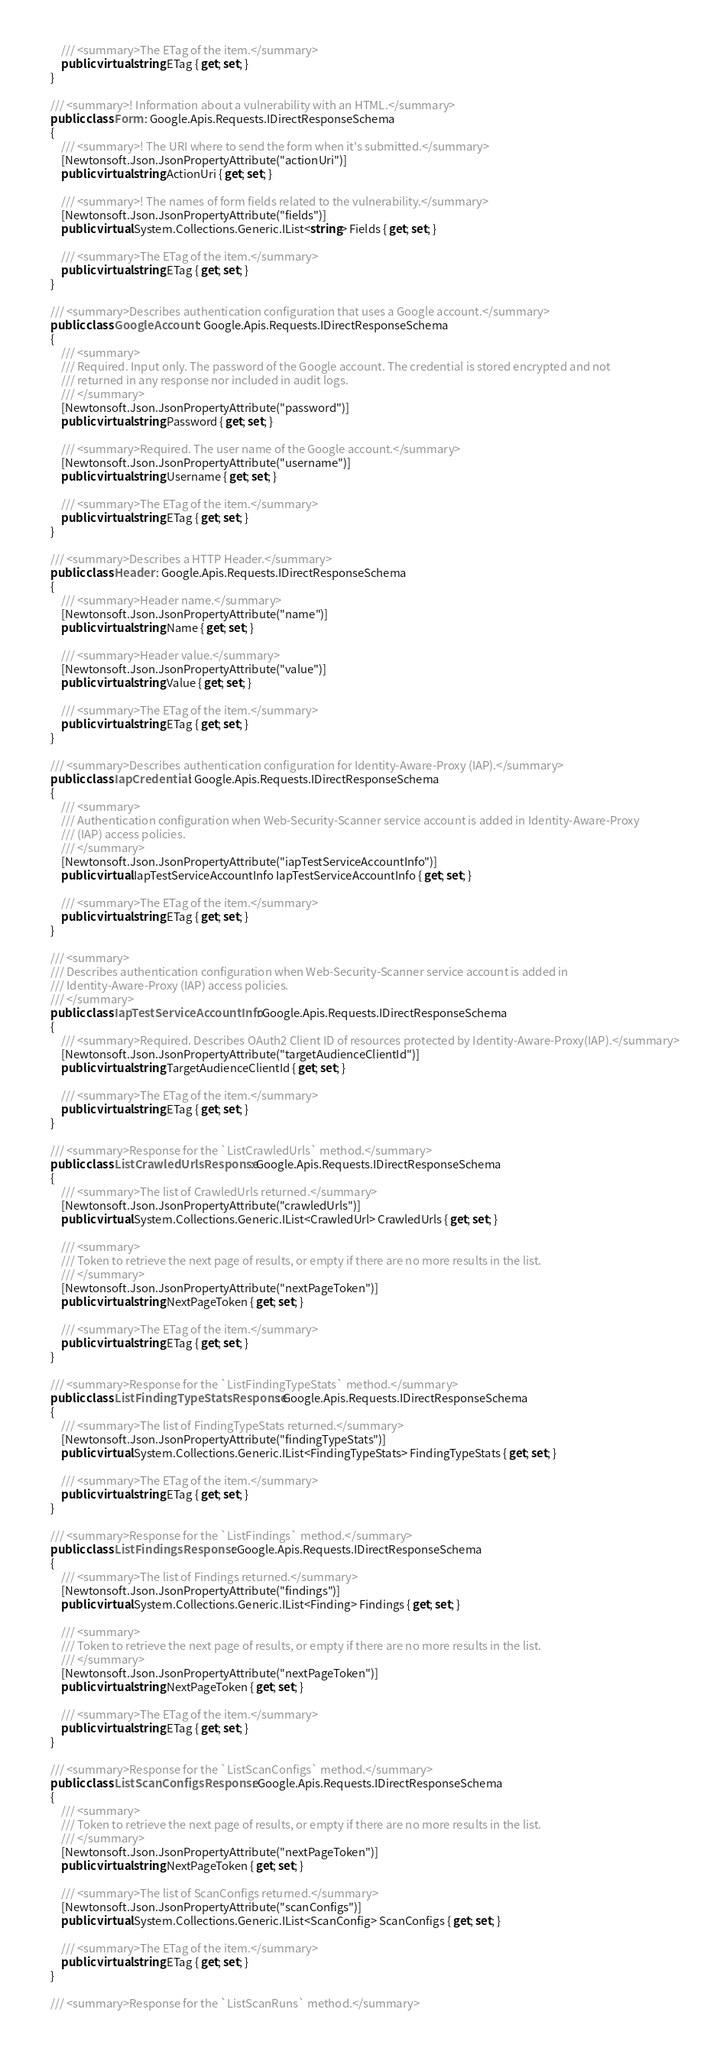Convert code to text. <code><loc_0><loc_0><loc_500><loc_500><_C#_>
        /// <summary>The ETag of the item.</summary>
        public virtual string ETag { get; set; }
    }

    /// <summary>! Information about a vulnerability with an HTML.</summary>
    public class Form : Google.Apis.Requests.IDirectResponseSchema
    {
        /// <summary>! The URI where to send the form when it's submitted.</summary>
        [Newtonsoft.Json.JsonPropertyAttribute("actionUri")]
        public virtual string ActionUri { get; set; }

        /// <summary>! The names of form fields related to the vulnerability.</summary>
        [Newtonsoft.Json.JsonPropertyAttribute("fields")]
        public virtual System.Collections.Generic.IList<string> Fields { get; set; }

        /// <summary>The ETag of the item.</summary>
        public virtual string ETag { get; set; }
    }

    /// <summary>Describes authentication configuration that uses a Google account.</summary>
    public class GoogleAccount : Google.Apis.Requests.IDirectResponseSchema
    {
        /// <summary>
        /// Required. Input only. The password of the Google account. The credential is stored encrypted and not
        /// returned in any response nor included in audit logs.
        /// </summary>
        [Newtonsoft.Json.JsonPropertyAttribute("password")]
        public virtual string Password { get; set; }

        /// <summary>Required. The user name of the Google account.</summary>
        [Newtonsoft.Json.JsonPropertyAttribute("username")]
        public virtual string Username { get; set; }

        /// <summary>The ETag of the item.</summary>
        public virtual string ETag { get; set; }
    }

    /// <summary>Describes a HTTP Header.</summary>
    public class Header : Google.Apis.Requests.IDirectResponseSchema
    {
        /// <summary>Header name.</summary>
        [Newtonsoft.Json.JsonPropertyAttribute("name")]
        public virtual string Name { get; set; }

        /// <summary>Header value.</summary>
        [Newtonsoft.Json.JsonPropertyAttribute("value")]
        public virtual string Value { get; set; }

        /// <summary>The ETag of the item.</summary>
        public virtual string ETag { get; set; }
    }

    /// <summary>Describes authentication configuration for Identity-Aware-Proxy (IAP).</summary>
    public class IapCredential : Google.Apis.Requests.IDirectResponseSchema
    {
        /// <summary>
        /// Authentication configuration when Web-Security-Scanner service account is added in Identity-Aware-Proxy
        /// (IAP) access policies.
        /// </summary>
        [Newtonsoft.Json.JsonPropertyAttribute("iapTestServiceAccountInfo")]
        public virtual IapTestServiceAccountInfo IapTestServiceAccountInfo { get; set; }

        /// <summary>The ETag of the item.</summary>
        public virtual string ETag { get; set; }
    }

    /// <summary>
    /// Describes authentication configuration when Web-Security-Scanner service account is added in
    /// Identity-Aware-Proxy (IAP) access policies.
    /// </summary>
    public class IapTestServiceAccountInfo : Google.Apis.Requests.IDirectResponseSchema
    {
        /// <summary>Required. Describes OAuth2 Client ID of resources protected by Identity-Aware-Proxy(IAP).</summary>
        [Newtonsoft.Json.JsonPropertyAttribute("targetAudienceClientId")]
        public virtual string TargetAudienceClientId { get; set; }

        /// <summary>The ETag of the item.</summary>
        public virtual string ETag { get; set; }
    }

    /// <summary>Response for the `ListCrawledUrls` method.</summary>
    public class ListCrawledUrlsResponse : Google.Apis.Requests.IDirectResponseSchema
    {
        /// <summary>The list of CrawledUrls returned.</summary>
        [Newtonsoft.Json.JsonPropertyAttribute("crawledUrls")]
        public virtual System.Collections.Generic.IList<CrawledUrl> CrawledUrls { get; set; }

        /// <summary>
        /// Token to retrieve the next page of results, or empty if there are no more results in the list.
        /// </summary>
        [Newtonsoft.Json.JsonPropertyAttribute("nextPageToken")]
        public virtual string NextPageToken { get; set; }

        /// <summary>The ETag of the item.</summary>
        public virtual string ETag { get; set; }
    }

    /// <summary>Response for the `ListFindingTypeStats` method.</summary>
    public class ListFindingTypeStatsResponse : Google.Apis.Requests.IDirectResponseSchema
    {
        /// <summary>The list of FindingTypeStats returned.</summary>
        [Newtonsoft.Json.JsonPropertyAttribute("findingTypeStats")]
        public virtual System.Collections.Generic.IList<FindingTypeStats> FindingTypeStats { get; set; }

        /// <summary>The ETag of the item.</summary>
        public virtual string ETag { get; set; }
    }

    /// <summary>Response for the `ListFindings` method.</summary>
    public class ListFindingsResponse : Google.Apis.Requests.IDirectResponseSchema
    {
        /// <summary>The list of Findings returned.</summary>
        [Newtonsoft.Json.JsonPropertyAttribute("findings")]
        public virtual System.Collections.Generic.IList<Finding> Findings { get; set; }

        /// <summary>
        /// Token to retrieve the next page of results, or empty if there are no more results in the list.
        /// </summary>
        [Newtonsoft.Json.JsonPropertyAttribute("nextPageToken")]
        public virtual string NextPageToken { get; set; }

        /// <summary>The ETag of the item.</summary>
        public virtual string ETag { get; set; }
    }

    /// <summary>Response for the `ListScanConfigs` method.</summary>
    public class ListScanConfigsResponse : Google.Apis.Requests.IDirectResponseSchema
    {
        /// <summary>
        /// Token to retrieve the next page of results, or empty if there are no more results in the list.
        /// </summary>
        [Newtonsoft.Json.JsonPropertyAttribute("nextPageToken")]
        public virtual string NextPageToken { get; set; }

        /// <summary>The list of ScanConfigs returned.</summary>
        [Newtonsoft.Json.JsonPropertyAttribute("scanConfigs")]
        public virtual System.Collections.Generic.IList<ScanConfig> ScanConfigs { get; set; }

        /// <summary>The ETag of the item.</summary>
        public virtual string ETag { get; set; }
    }

    /// <summary>Response for the `ListScanRuns` method.</summary></code> 